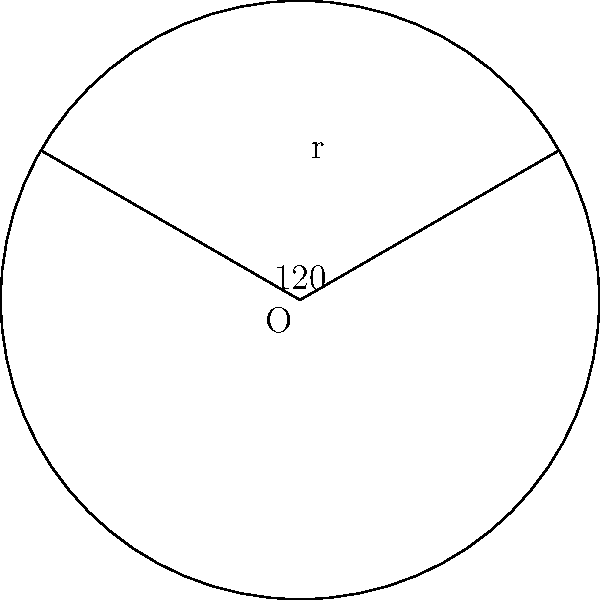Imagine a hockey puck as a perfect circle with a radius of 3 inches. If you're writing a song about a memorable shot that carved out a 120° sector of the puck, what would be the area of that sector in square inches? Round your answer to two decimal places. To solve this problem, let's follow these steps:

1) The formula for the area of a sector is:
   $A = \frac{\theta}{360°} \pi r^2$
   where $\theta$ is the central angle in degrees, and $r$ is the radius.

2) We're given:
   $\theta = 120°$
   $r = 3$ inches

3) Let's substitute these values into our formula:
   $A = \frac{120°}{360°} \pi (3\text{ in})^2$

4) Simplify:
   $A = \frac{1}{3} \pi (9\text{ in}^2)$
   $A = 3\pi\text{ in}^2$

5) Calculate:
   $A = 3 * 3.14159...\text{ in}^2$
   $A \approx 9.4248\text{ in}^2$

6) Rounding to two decimal places:
   $A \approx 9.42\text{ in}^2$
Answer: $9.42\text{ in}^2$ 